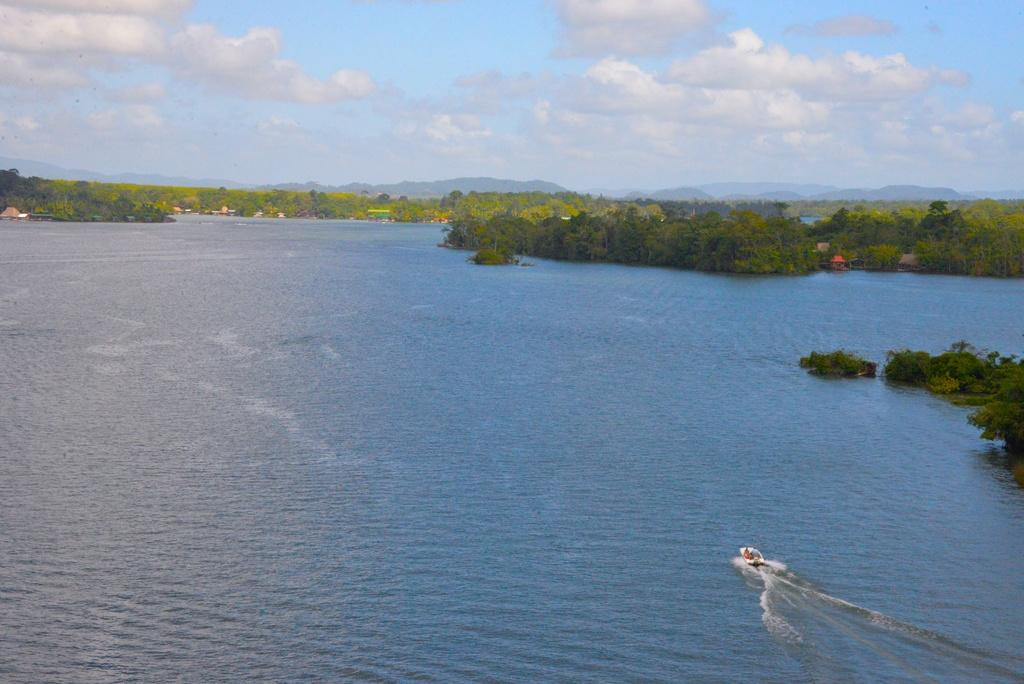What is the main subject of the image? The main subject of the image is a boat. Where is the boat located? The boat is on a river. What type of natural features can be seen in the image? There are trees and hills visible in the image. What is visible in the sky in the image? The sky is visible in the image, and clouds are present. What advice does the boat give to the trees in the image? The boat does not give any advice in the image, as it is an inanimate object and cannot communicate. 